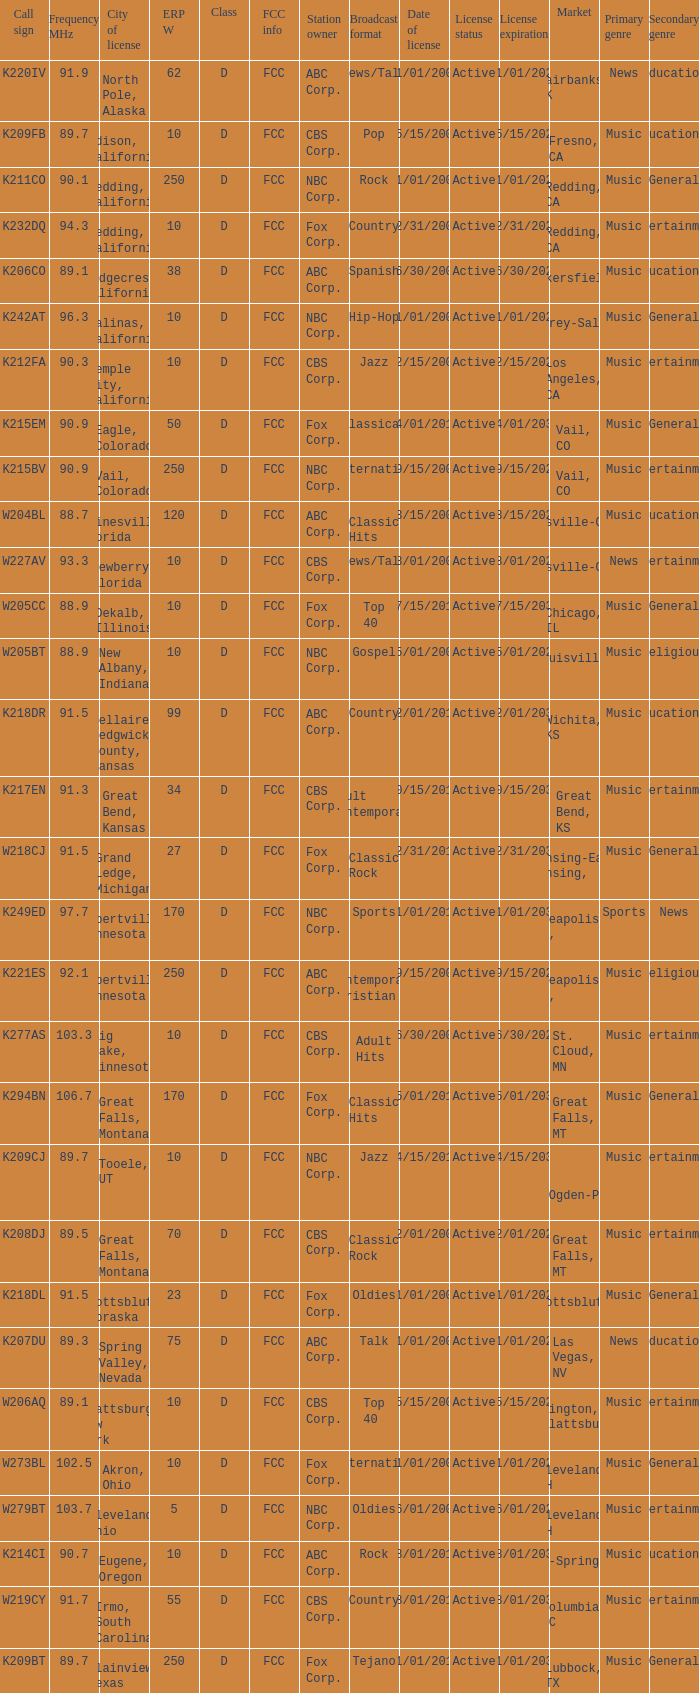What is the class of the translator with 10 ERP W and a call sign of w273bl? D. 